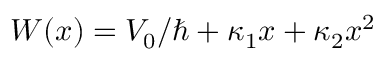<formula> <loc_0><loc_0><loc_500><loc_500>W ( x ) = V _ { 0 } / \hbar { + } \kappa _ { 1 } x + \kappa _ { 2 } x ^ { 2 }</formula> 